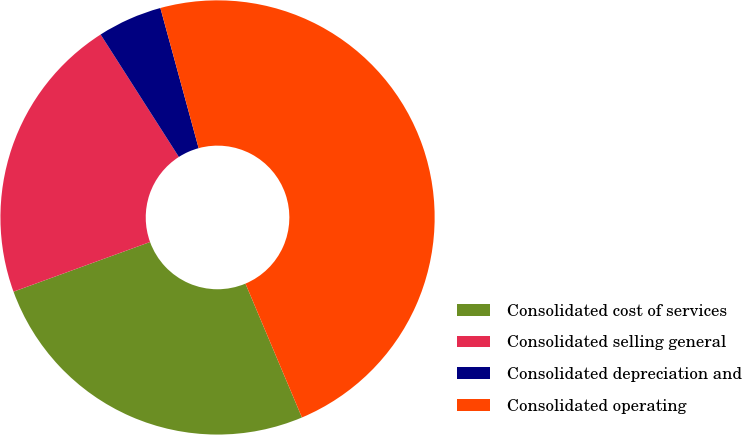Convert chart to OTSL. <chart><loc_0><loc_0><loc_500><loc_500><pie_chart><fcel>Consolidated cost of services<fcel>Consolidated selling general<fcel>Consolidated depreciation and<fcel>Consolidated operating<nl><fcel>25.8%<fcel>21.5%<fcel>4.81%<fcel>47.88%<nl></chart> 